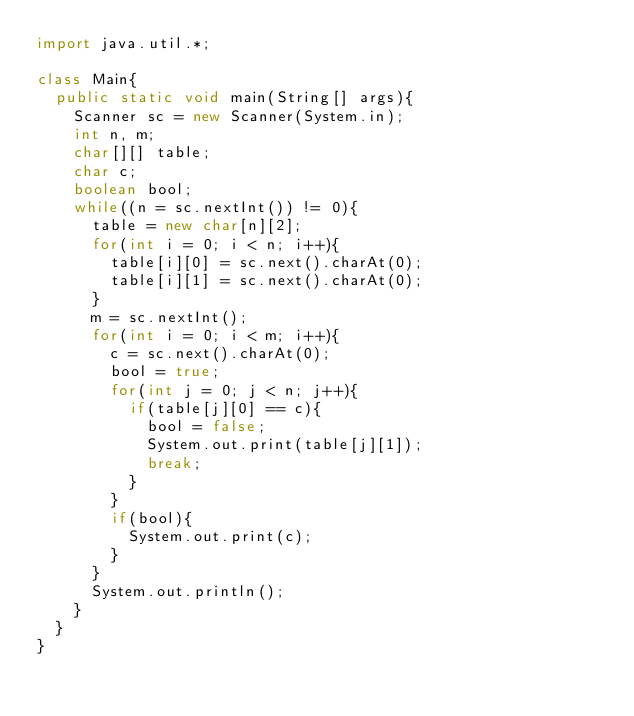<code> <loc_0><loc_0><loc_500><loc_500><_Java_>import java.util.*;

class Main{
	public static void main(String[] args){
		Scanner sc = new Scanner(System.in);
		int n, m;
		char[][] table;
		char c;
		boolean bool;
		while((n = sc.nextInt()) != 0){
			table = new char[n][2];
			for(int i = 0; i < n; i++){
				table[i][0] = sc.next().charAt(0);
				table[i][1] = sc.next().charAt(0);
			}
			m = sc.nextInt();
			for(int i = 0; i < m; i++){
				c = sc.next().charAt(0);
				bool = true;
				for(int j = 0; j < n; j++){
					if(table[j][0] == c){
						bool = false;
						System.out.print(table[j][1]);
						break;
					}
				}
				if(bool){
					System.out.print(c);
				}
			}
			System.out.println();
		}
	}
}</code> 